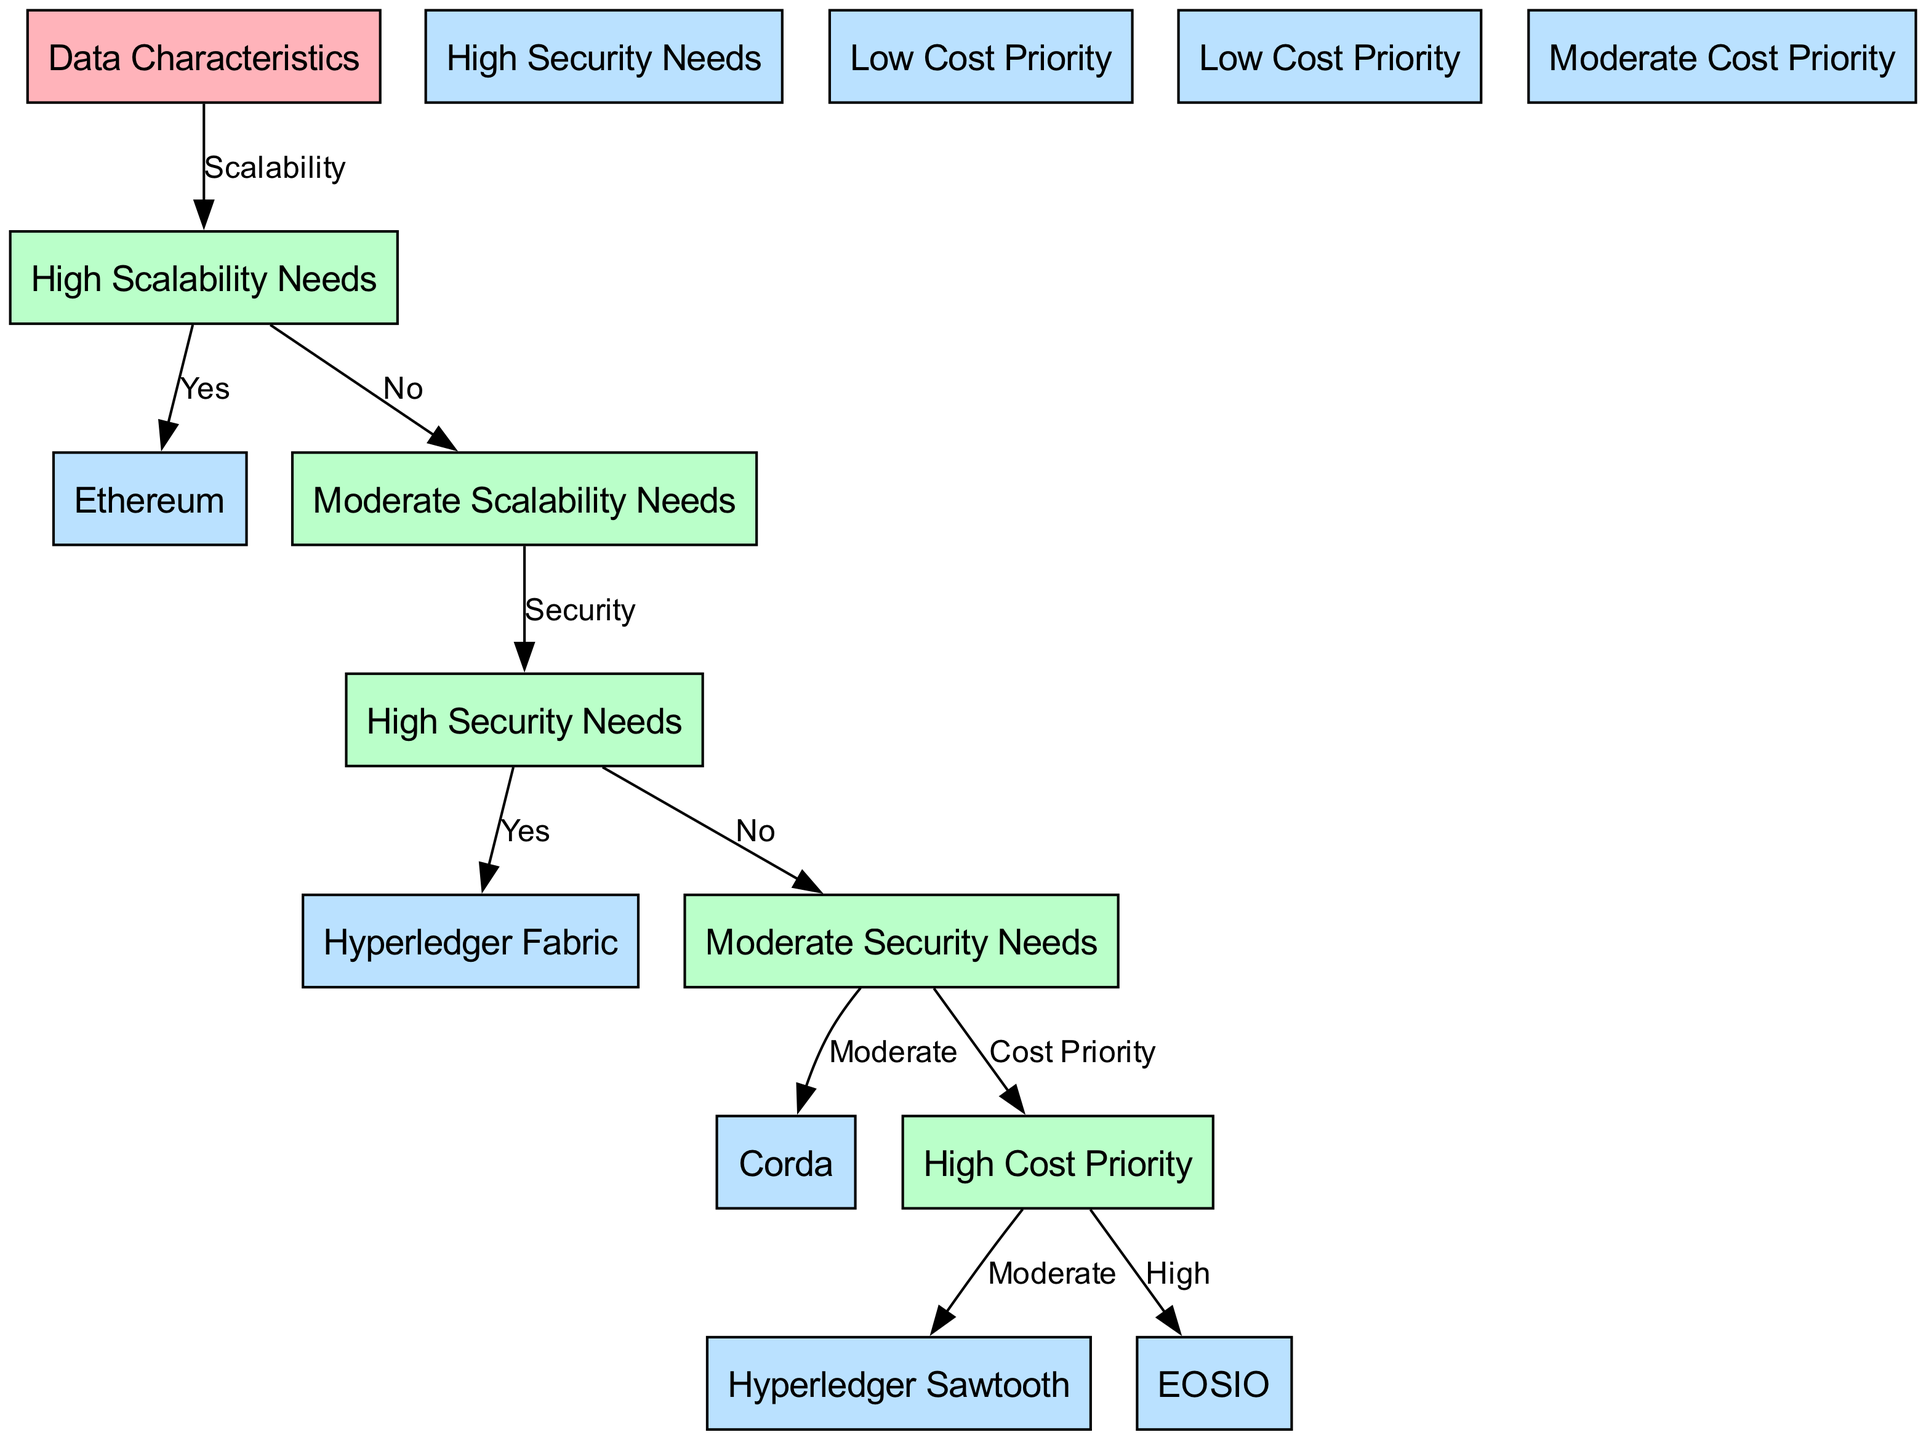What is the first decision point in the diagram? The diagram begins with the node "Data Characteristics," which signifies the starting point for the decision-making process regarding blockchain frameworks.
Answer: Data Characteristics How many nodes are present in the diagram? By counting the nodes listed in the data, we find there are fifteen nodes in total.
Answer: 15 Which blockchain framework is chosen for high scalability and high security needs? The flow from the "High Scalability Needs" node leads to "Ethereum," and since it also meets the "High Security Needs," Ethereum is the correct choice for these criteria.
Answer: Ethereum If scalability needs are low and security needs are moderate, which blockchain framework is recommended? Following the flow from "Low Scalability Needs" leads to "Moderate Scalability Needs," and then checking "Security" shows that a "Moderate" security need indicates "Corda" is the appropriate choice.
Answer: Corda What are the options given for high cost priority after identifying moderate security needs? From the "Moderate Security Needs" node, it points to "Cost Priority" followed by "High," indicating "EOSIO" as a suitable option for high cost priority requirements.
Answer: EOSIO Which node represents blockchain framework options with low cost priority and moderate scalability needs? The flow indicates that "Low Cost Priority" and "Moderate Scalability Needs" leads to "Hyperledger Sawtooth," which represents these criteria together in the diagram.
Answer: Hyperledger Sawtooth What is the relationship between "High Security Needs" and "Hyperledger Fabric"? The diagram illustrates that if "High Security Needs" is confirmed (Yes), the next node directs to "Hyperledger Fabric," establishing a direct association between high security and this blockchain framework.
Answer: Hyperledger Fabric What is the decision made if scalability needs are low, and security needs are high? In this case, the "Low Scalability Needs" leads to "High Security Needs," which confirms "Hyperledger Fabric" as the recommended framework when both conditions are met.
Answer: Hyperledger Fabric What is indicated by the edge connecting "Cost Priority" with "Moderate"? This edge suggests that if the cost priority is moderate, the appropriate option is "Corda," allowing for a choice based on balanced cost considerations.
Answer: Corda 